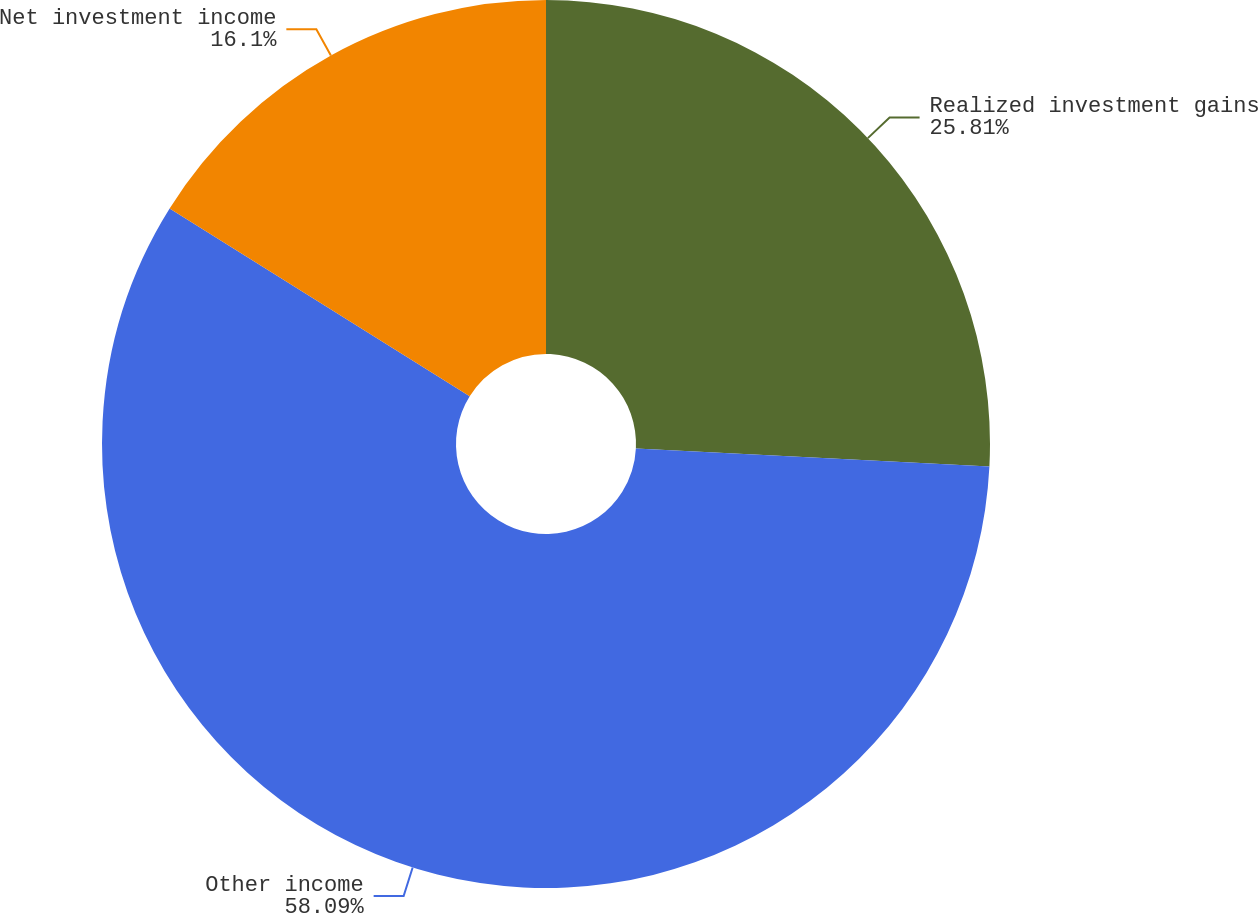<chart> <loc_0><loc_0><loc_500><loc_500><pie_chart><fcel>Realized investment gains<fcel>Other income<fcel>Net investment income<nl><fcel>25.81%<fcel>58.09%<fcel>16.1%<nl></chart> 